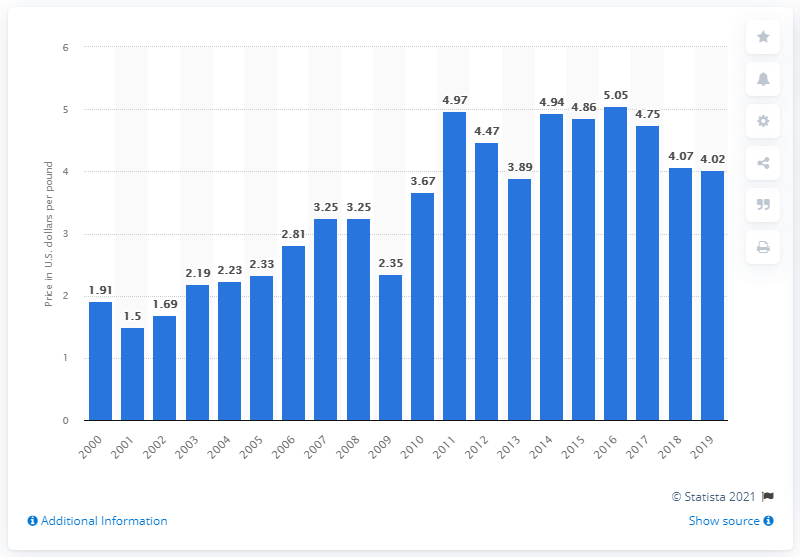Indicate a few pertinent items in this graphic. In 2016, the average price per pound of Pacific halibut was $5.05. 